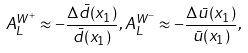<formula> <loc_0><loc_0><loc_500><loc_500>A _ { L } ^ { W ^ { + } } \approx - \frac { \Delta \bar { d } ( x _ { 1 } ) } { \bar { d } ( x _ { 1 } ) } , A _ { L } ^ { W ^ { - } } \approx - \frac { \Delta \bar { u } ( x _ { 1 } ) } { \bar { u } ( x _ { 1 } ) } ,</formula> 